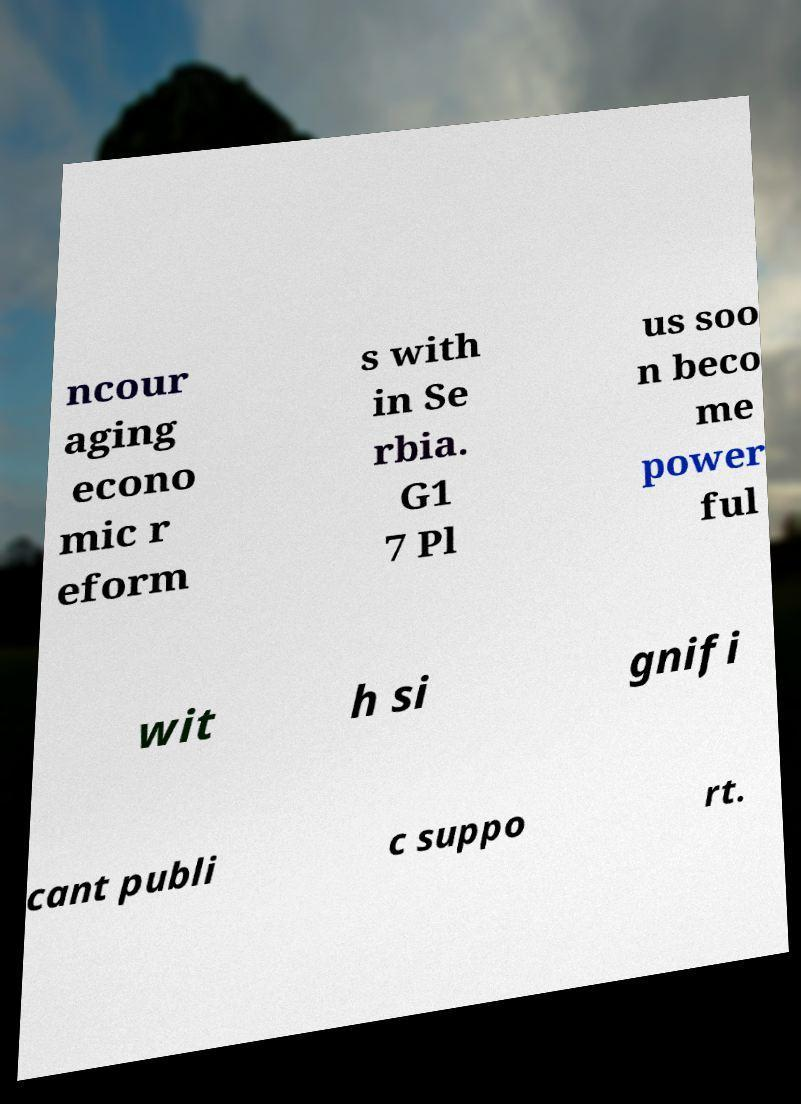There's text embedded in this image that I need extracted. Can you transcribe it verbatim? ncour aging econo mic r eform s with in Se rbia. G1 7 Pl us soo n beco me power ful wit h si gnifi cant publi c suppo rt. 